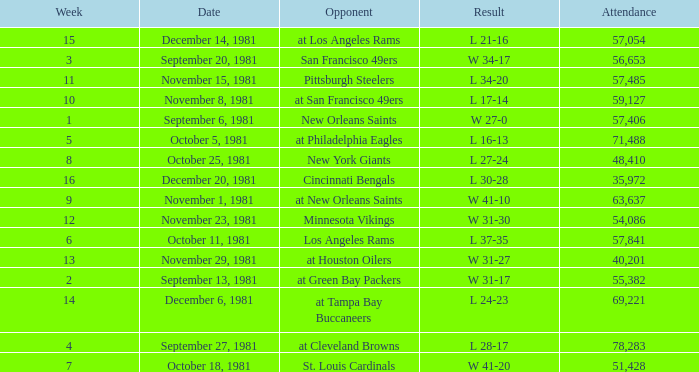What was the average number of attendance for the game on November 29, 1981 played after week 13? None. 